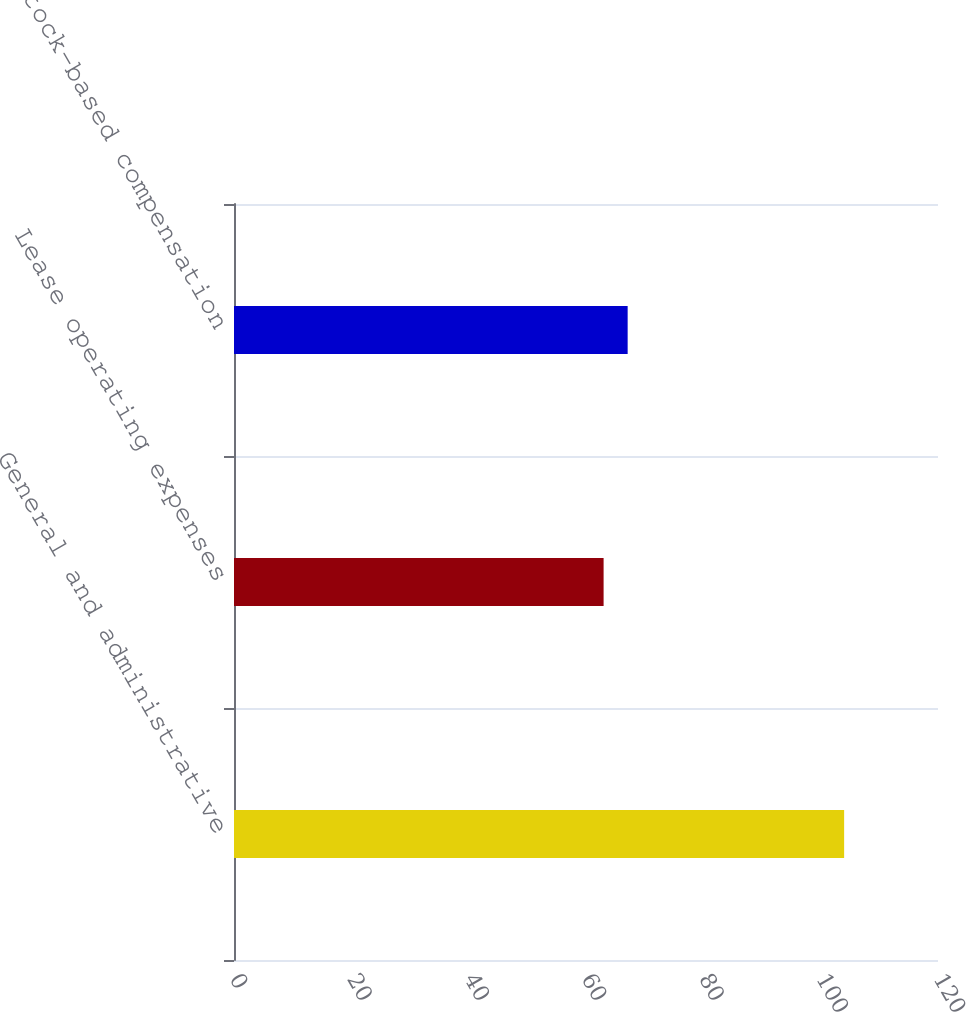Convert chart to OTSL. <chart><loc_0><loc_0><loc_500><loc_500><bar_chart><fcel>General and administrative<fcel>Lease operating expenses<fcel>Stock-based compensation<nl><fcel>104<fcel>63<fcel>67.1<nl></chart> 